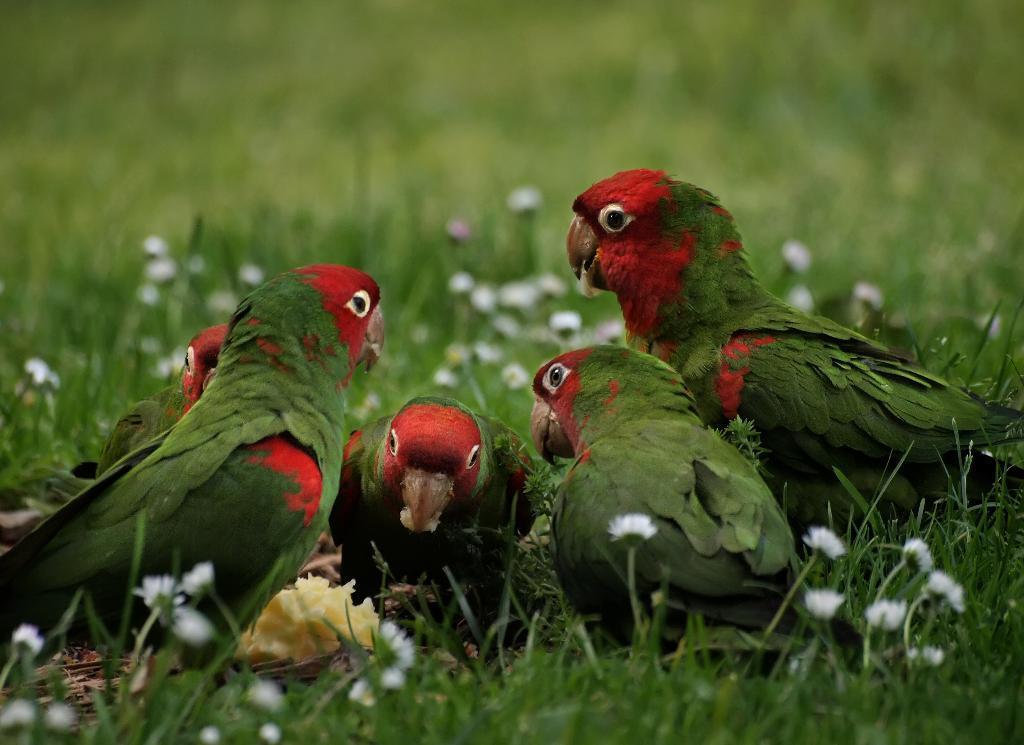Please provide a concise description of this image. This image consists of parrots in green and red color are eating. At the bottom, there is green grass. The background is blurred. 